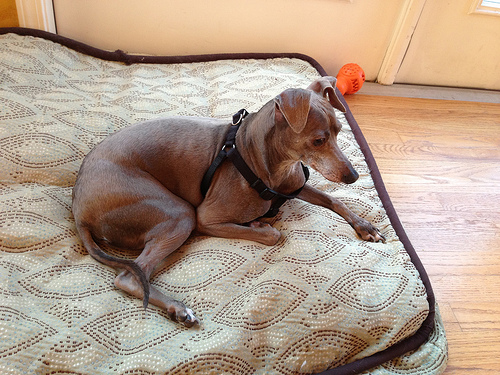<image>
Is the dog on the floor? No. The dog is not positioned on the floor. They may be near each other, but the dog is not supported by or resting on top of the floor. 